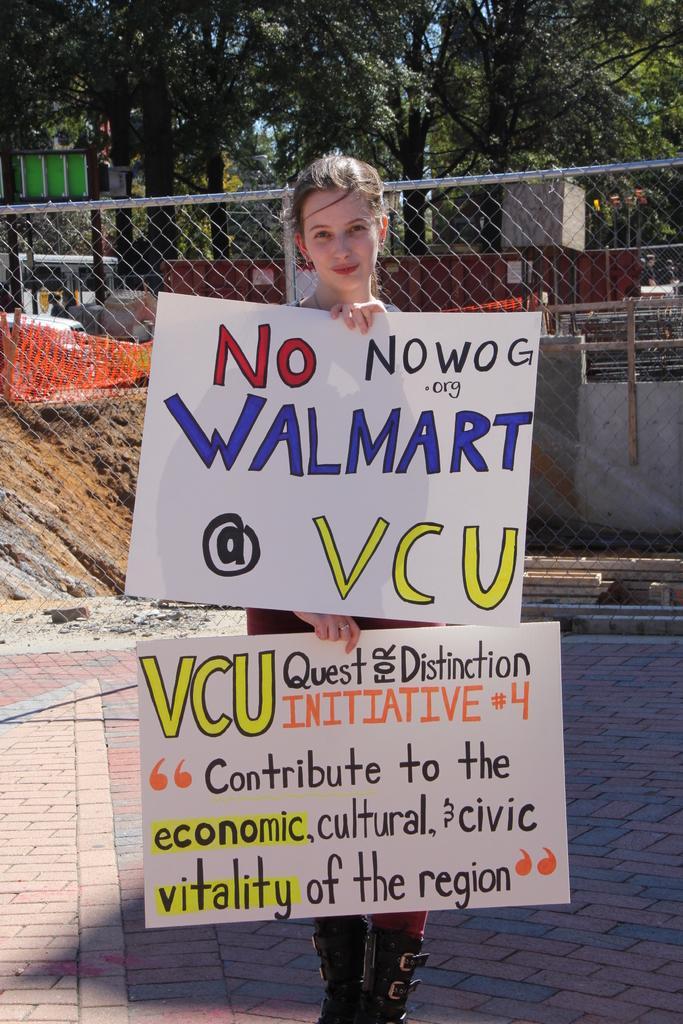Could you give a brief overview of what you see in this image? In the image we can see a woman standing, wearing clothes and boots and the woman is holding two posters in hand. Here we can see footpath, fence, wall, board and trees. 